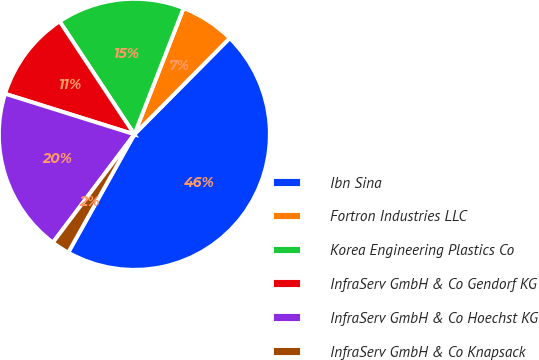Convert chart. <chart><loc_0><loc_0><loc_500><loc_500><pie_chart><fcel>Ibn Sina<fcel>Fortron Industries LLC<fcel>Korea Engineering Plastics Co<fcel>InfraServ GmbH & Co Gendorf KG<fcel>InfraServ GmbH & Co Hoechst KG<fcel>InfraServ GmbH & Co Knapsack<nl><fcel>45.7%<fcel>6.51%<fcel>15.22%<fcel>10.86%<fcel>19.57%<fcel>2.15%<nl></chart> 